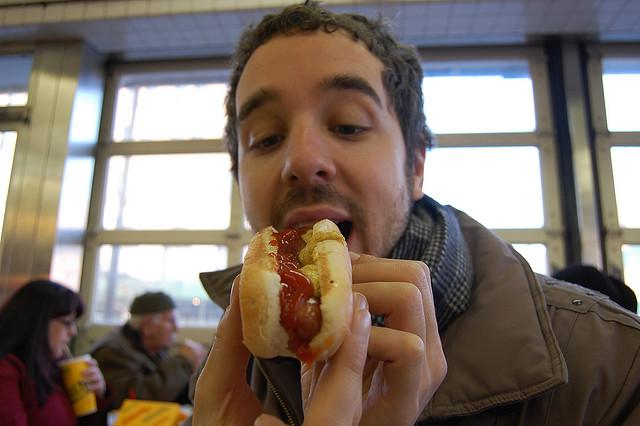What style of food is being served? hot dog 